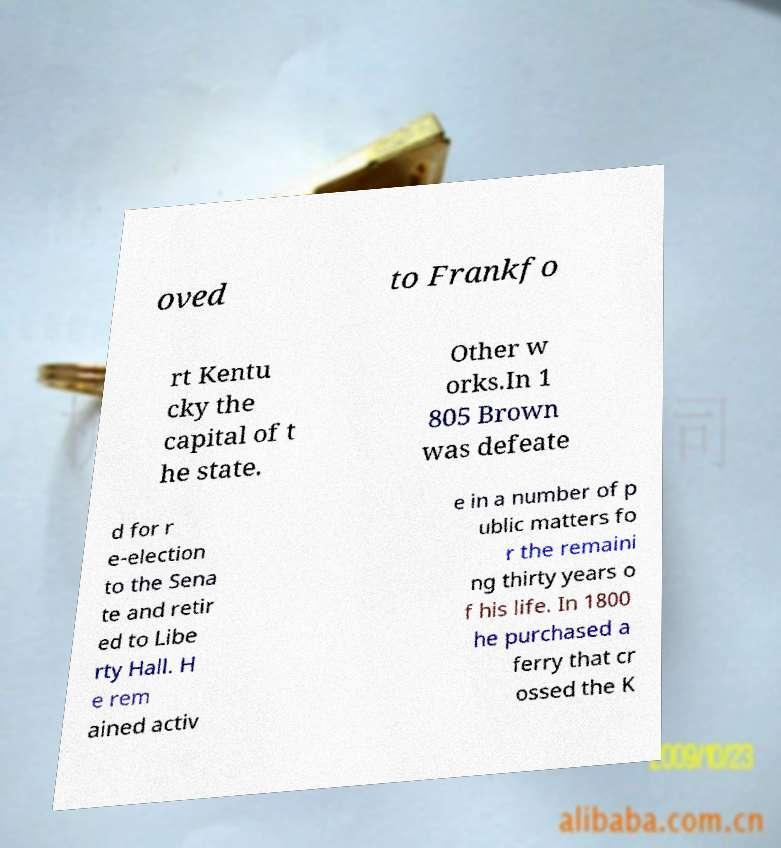Please read and relay the text visible in this image. What does it say? oved to Frankfo rt Kentu cky the capital of t he state. Other w orks.In 1 805 Brown was defeate d for r e-election to the Sena te and retir ed to Libe rty Hall. H e rem ained activ e in a number of p ublic matters fo r the remaini ng thirty years o f his life. In 1800 he purchased a ferry that cr ossed the K 